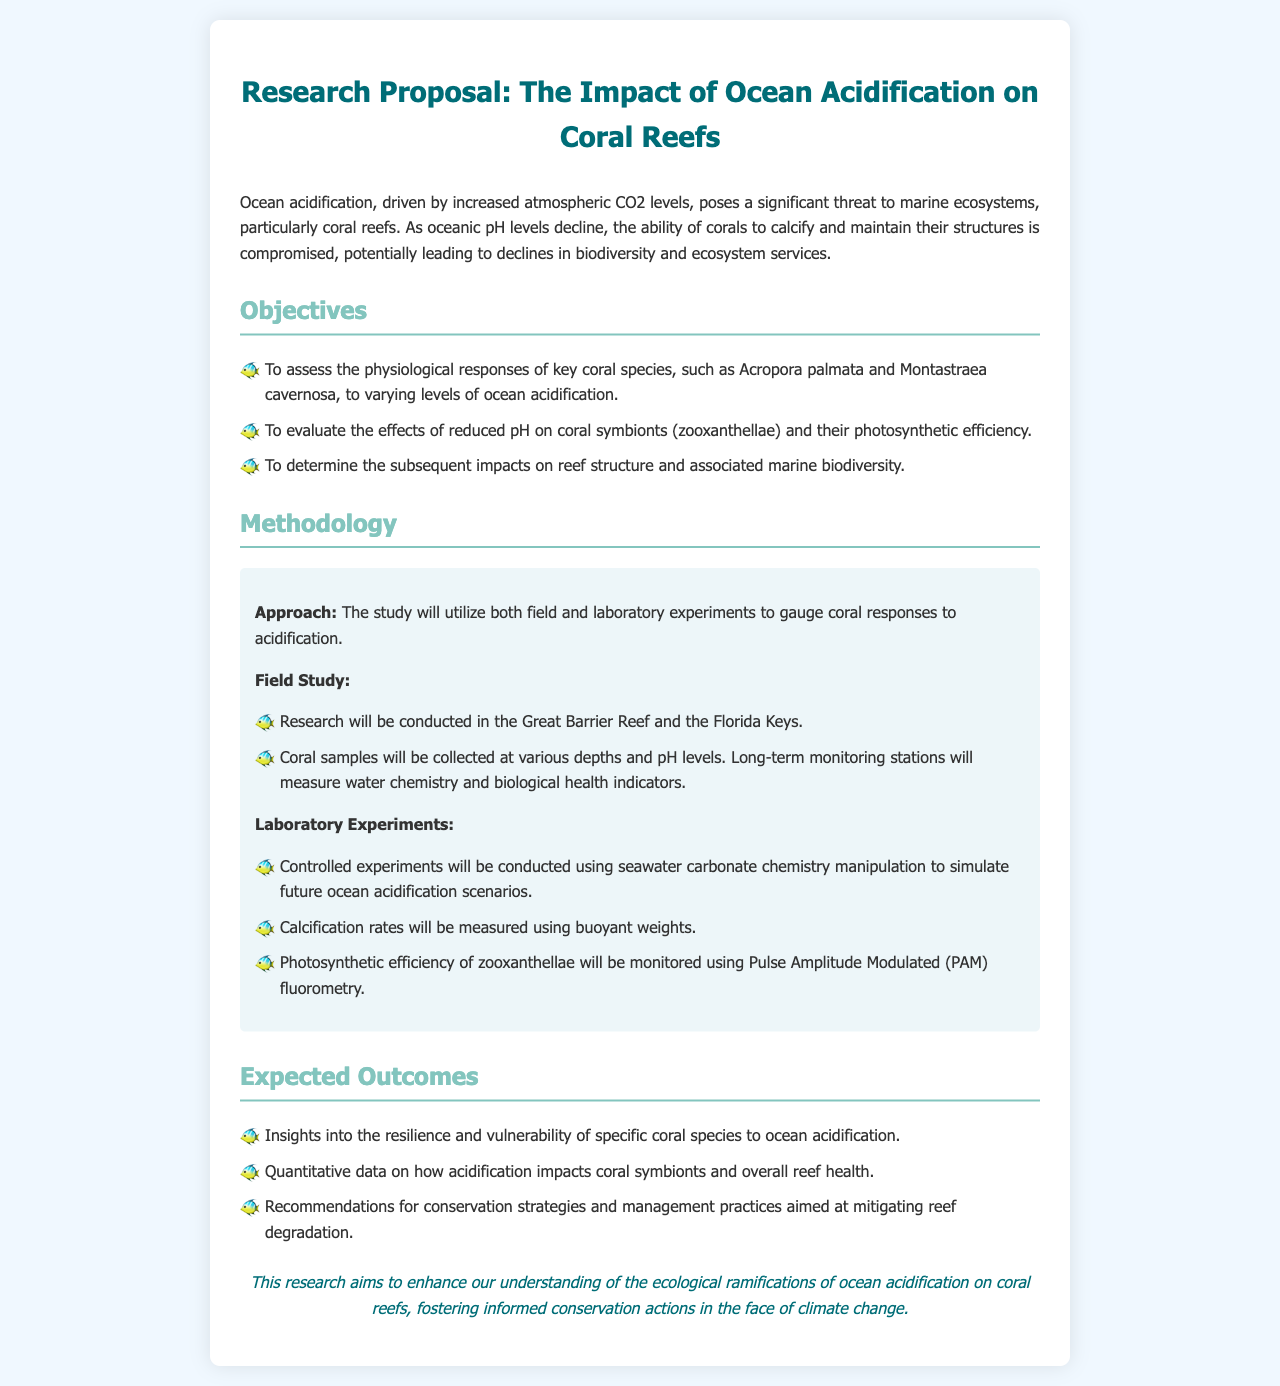What is the main threat to coral reefs mentioned in the proposal? The proposal states that ocean acidification, driven by increased atmospheric CO2 levels, poses a significant threat to marine ecosystems, particularly coral reefs.
Answer: ocean acidification What coral species are assessed in the study? The objectives list Acropora palmata and Montastraea cavernosa as the key coral species to be assessed.
Answer: Acropora palmata and Montastraea cavernosa What type of studies will be conducted in the research? The methodology outlines that both field and laboratory experiments will be utilized to gauge coral responses to acidification.
Answer: field and laboratory experiments Where will the field studies take place? The proposal mentions that research will be conducted in the Great Barrier Reef and the Florida Keys for the field studies.
Answer: Great Barrier Reef and Florida Keys What technology will be used to monitor photosynthetic efficiency? The methodology specifies that Pulse Amplitude Modulated (PAM) fluorometry will be used to monitor photosynthetic efficiency of zooxanthellae.
Answer: PAM fluorometry What is one of the expected outcomes of the research? The expected outcomes include insights into the resilience and vulnerability of specific coral species to ocean acidification.
Answer: resilience and vulnerability of specific coral species Which two factors does the proposal evaluate regarding coral symbionts? The proposal evaluates the effects of reduced pH on coral symbionts and their photosynthetic efficiency.
Answer: reduced pH and photosynthetic efficiency What is the ultimate goal of the research? The conclusion states that the research aims to enhance our understanding of the ecological ramifications of ocean acidification on coral reefs.
Answer: enhance our understanding 